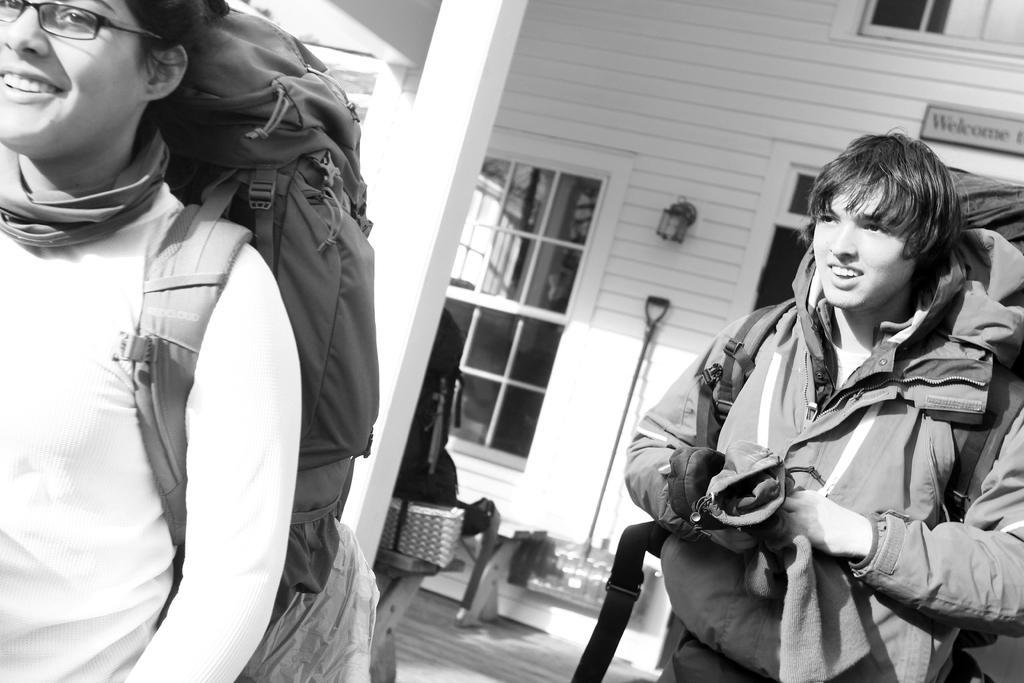Could you give a brief overview of what you see in this image? This is a black and white image. In the foreground of the image there are two people wearing bags. In the background of the image there is a white color building with windows. There is a board with some text. There is a light on the wall. 